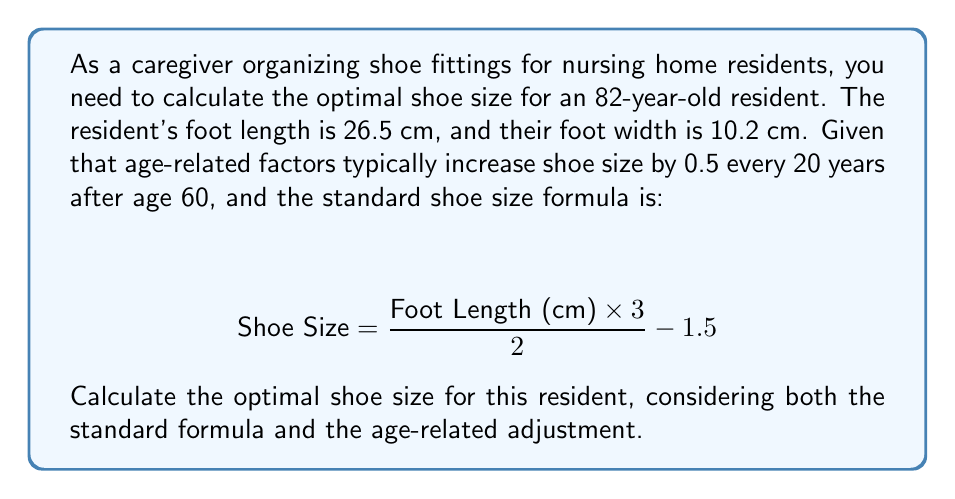Could you help me with this problem? To solve this problem, we'll follow these steps:

1. Calculate the base shoe size using the standard formula.
2. Determine the age-related adjustment.
3. Apply the age-related adjustment to the base shoe size.

Step 1: Calculate the base shoe size
Using the given formula:

$$ \text{Base Shoe Size} = \frac{\text{Foot Length (cm)} \times 3}{2} - 1.5 $$

Substituting the foot length of 26.5 cm:

$$ \text{Base Shoe Size} = \frac{26.5 \times 3}{2} - 1.5 $$
$$ = \frac{79.5}{2} - 1.5 $$
$$ = 39.75 - 1.5 $$
$$ = 38.25 $$

Step 2: Determine the age-related adjustment
The resident is 82 years old. The adjustment starts at age 60, so we need to account for 22 years of adjustment.

Years of adjustment = 82 - 60 = 22 years
Adjustment periods = 22 ÷ 20 = 1.1 periods

Total adjustment = 1.1 × 0.5 = 0.55

Step 3: Apply the age-related adjustment
Optimal shoe size = Base shoe size + Age-related adjustment
$$ \text{Optimal Shoe Size} = 38.25 + 0.55 = 38.8 $$

Since shoe sizes are typically given in whole or half sizes, we should round this to the nearest half size, which is 39.
Answer: The optimal shoe size for the 82-year-old resident is 39. 